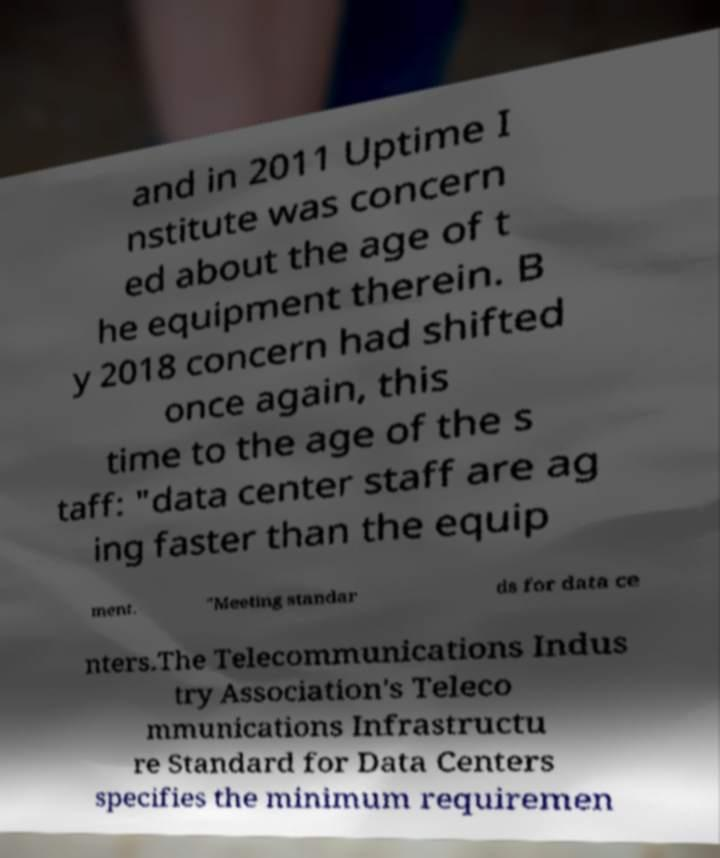Could you extract and type out the text from this image? and in 2011 Uptime I nstitute was concern ed about the age of t he equipment therein. B y 2018 concern had shifted once again, this time to the age of the s taff: "data center staff are ag ing faster than the equip ment. "Meeting standar ds for data ce nters.The Telecommunications Indus try Association's Teleco mmunications Infrastructu re Standard for Data Centers specifies the minimum requiremen 